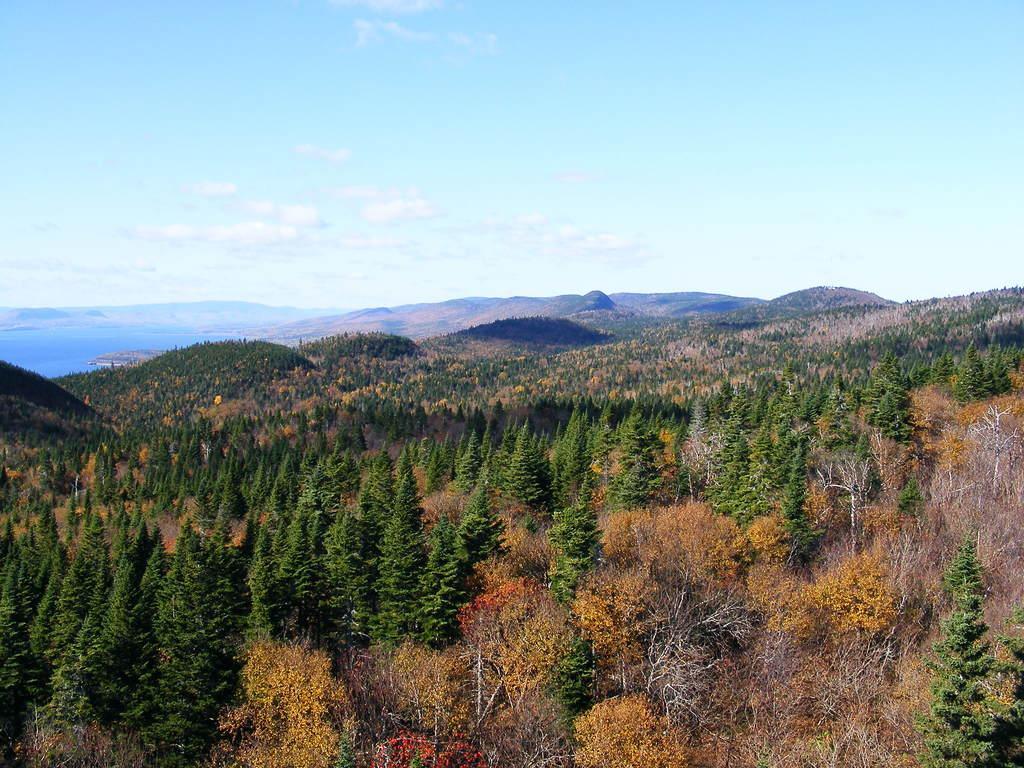In one or two sentences, can you explain what this image depicts? In the picture we can see, full of trees, some are orange in color and some are yellow in color and far away from it also we can see full of trees, hills and sky with clouds. 